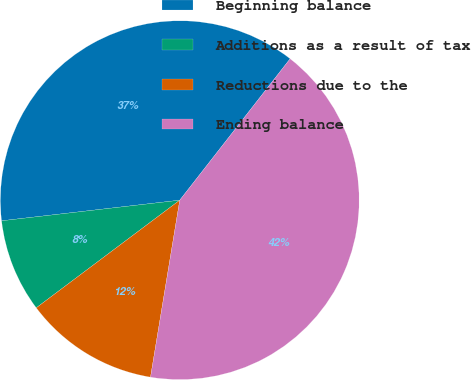Convert chart to OTSL. <chart><loc_0><loc_0><loc_500><loc_500><pie_chart><fcel>Beginning balance<fcel>Additions as a result of tax<fcel>Reductions due to the<fcel>Ending balance<nl><fcel>37.38%<fcel>8.41%<fcel>12.15%<fcel>42.06%<nl></chart> 